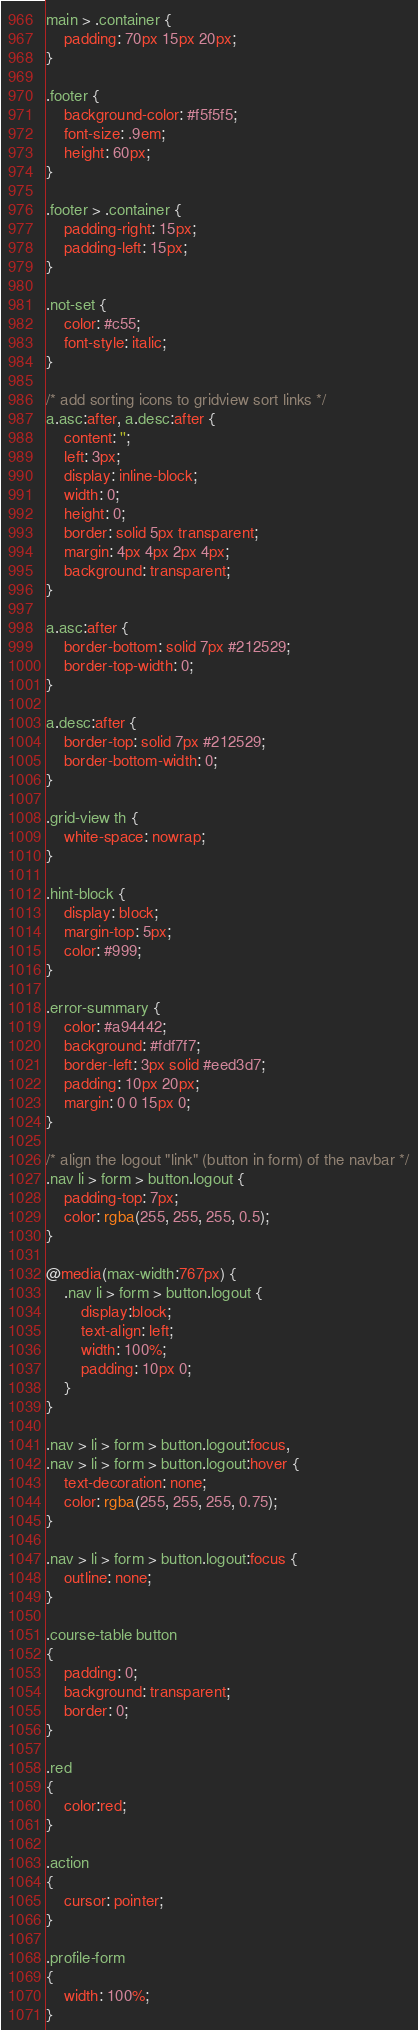Convert code to text. <code><loc_0><loc_0><loc_500><loc_500><_CSS_>main > .container {
    padding: 70px 15px 20px;
}

.footer {
    background-color: #f5f5f5;
    font-size: .9em;
    height: 60px;
}

.footer > .container {
    padding-right: 15px;
    padding-left: 15px;
}

.not-set {
    color: #c55;
    font-style: italic;
}

/* add sorting icons to gridview sort links */
a.asc:after, a.desc:after {
    content: '';
    left: 3px;
    display: inline-block;
    width: 0;
    height: 0;
    border: solid 5px transparent;
    margin: 4px 4px 2px 4px;
    background: transparent;
}

a.asc:after {
    border-bottom: solid 7px #212529;
    border-top-width: 0;
}

a.desc:after {
    border-top: solid 7px #212529;
    border-bottom-width: 0;
}

.grid-view th {
    white-space: nowrap;
}

.hint-block {
    display: block;
    margin-top: 5px;
    color: #999;
}

.error-summary {
    color: #a94442;
    background: #fdf7f7;
    border-left: 3px solid #eed3d7;
    padding: 10px 20px;
    margin: 0 0 15px 0;
}

/* align the logout "link" (button in form) of the navbar */
.nav li > form > button.logout {
    padding-top: 7px;
    color: rgba(255, 255, 255, 0.5);
}

@media(max-width:767px) {
    .nav li > form > button.logout {
        display:block;
        text-align: left;
        width: 100%;
        padding: 10px 0;
    }
}

.nav > li > form > button.logout:focus,
.nav > li > form > button.logout:hover {
    text-decoration: none;
    color: rgba(255, 255, 255, 0.75);
}

.nav > li > form > button.logout:focus {
    outline: none;
}

.course-table button
{
    padding: 0;
    background: transparent;
    border: 0;
}

.red
{
    color:red;
}

.action
{
    cursor: pointer;
}

.profile-form
{
    width: 100%;
}</code> 